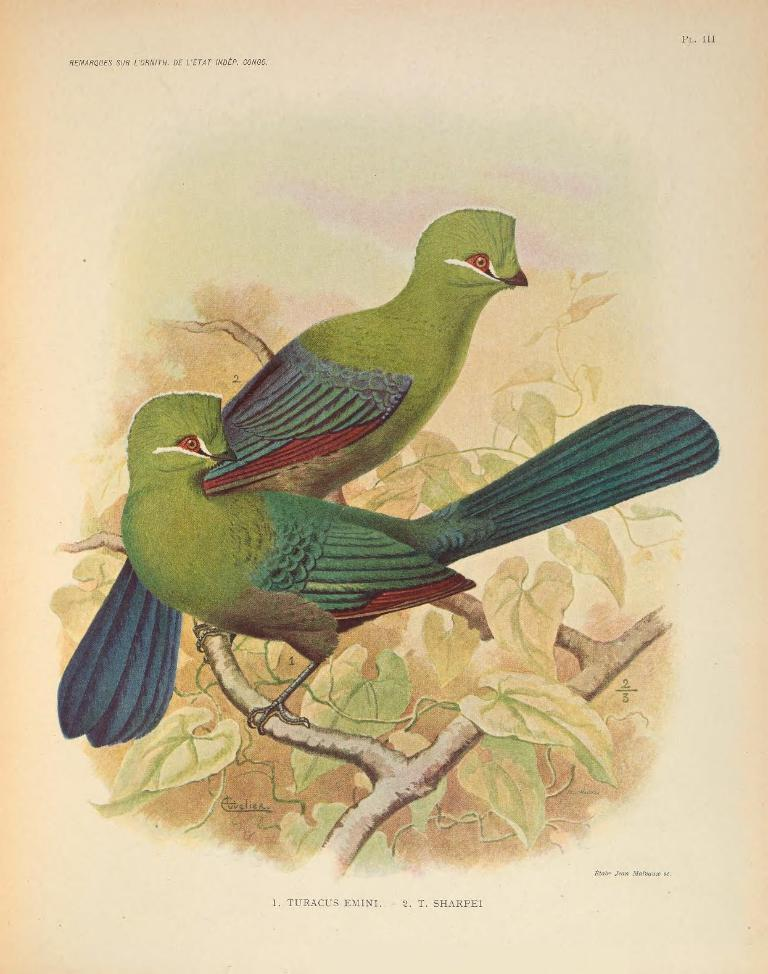What is depicted on the page in the image? The page contains a painting of two birds. How would you describe the appearance of the birds? The birds are beautiful. What medium is used to create the painting? The birds are painted on the paper. Where are the birds located in the painting? Both birds are sitting on the branch of a tree. What type of juice can be seen in the painting? There is no juice present in the painting; it features a painting of two birds sitting on a tree branch. 